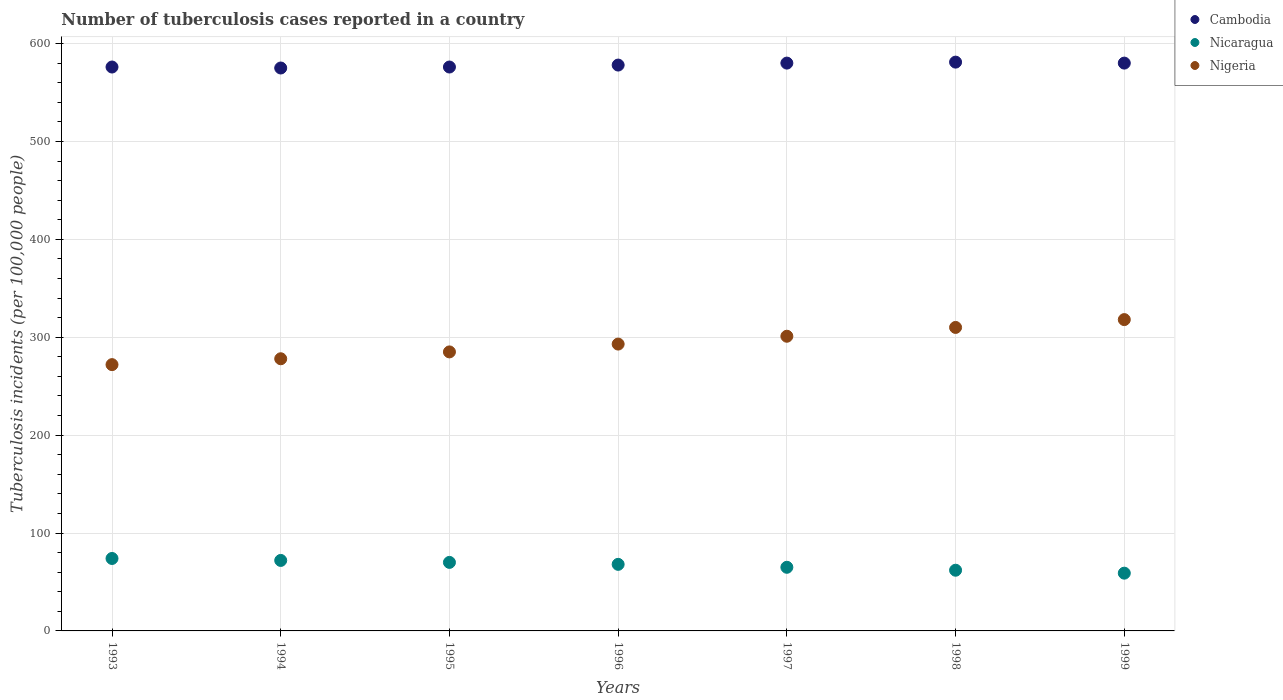How many different coloured dotlines are there?
Your answer should be compact. 3. What is the number of tuberculosis cases reported in in Nigeria in 1995?
Provide a short and direct response. 285. Across all years, what is the maximum number of tuberculosis cases reported in in Cambodia?
Offer a very short reply. 581. Across all years, what is the minimum number of tuberculosis cases reported in in Nicaragua?
Offer a very short reply. 59. In which year was the number of tuberculosis cases reported in in Cambodia maximum?
Make the answer very short. 1998. What is the total number of tuberculosis cases reported in in Nigeria in the graph?
Ensure brevity in your answer.  2057. What is the difference between the number of tuberculosis cases reported in in Nigeria in 1993 and the number of tuberculosis cases reported in in Cambodia in 1994?
Provide a succinct answer. -303. What is the average number of tuberculosis cases reported in in Cambodia per year?
Your answer should be compact. 578. In the year 1998, what is the difference between the number of tuberculosis cases reported in in Nicaragua and number of tuberculosis cases reported in in Nigeria?
Provide a succinct answer. -248. In how many years, is the number of tuberculosis cases reported in in Nicaragua greater than 140?
Make the answer very short. 0. What is the ratio of the number of tuberculosis cases reported in in Nigeria in 1993 to that in 1999?
Provide a succinct answer. 0.86. Is the number of tuberculosis cases reported in in Nicaragua in 1995 less than that in 1996?
Give a very brief answer. No. What is the difference between the highest and the second highest number of tuberculosis cases reported in in Nicaragua?
Give a very brief answer. 2. What is the difference between the highest and the lowest number of tuberculosis cases reported in in Nicaragua?
Offer a terse response. 15. Does the number of tuberculosis cases reported in in Cambodia monotonically increase over the years?
Offer a terse response. No. Is the number of tuberculosis cases reported in in Nicaragua strictly greater than the number of tuberculosis cases reported in in Nigeria over the years?
Make the answer very short. No. Is the number of tuberculosis cases reported in in Cambodia strictly less than the number of tuberculosis cases reported in in Nicaragua over the years?
Your answer should be compact. No. How many dotlines are there?
Provide a succinct answer. 3. How many years are there in the graph?
Your answer should be compact. 7. What is the difference between two consecutive major ticks on the Y-axis?
Give a very brief answer. 100. Are the values on the major ticks of Y-axis written in scientific E-notation?
Ensure brevity in your answer.  No. Does the graph contain any zero values?
Offer a terse response. No. Does the graph contain grids?
Your answer should be very brief. Yes. Where does the legend appear in the graph?
Make the answer very short. Top right. How are the legend labels stacked?
Provide a succinct answer. Vertical. What is the title of the graph?
Your response must be concise. Number of tuberculosis cases reported in a country. What is the label or title of the Y-axis?
Make the answer very short. Tuberculosis incidents (per 100,0 people). What is the Tuberculosis incidents (per 100,000 people) in Cambodia in 1993?
Offer a very short reply. 576. What is the Tuberculosis incidents (per 100,000 people) in Nicaragua in 1993?
Offer a terse response. 74. What is the Tuberculosis incidents (per 100,000 people) of Nigeria in 1993?
Provide a short and direct response. 272. What is the Tuberculosis incidents (per 100,000 people) of Cambodia in 1994?
Give a very brief answer. 575. What is the Tuberculosis incidents (per 100,000 people) of Nigeria in 1994?
Make the answer very short. 278. What is the Tuberculosis incidents (per 100,000 people) in Cambodia in 1995?
Give a very brief answer. 576. What is the Tuberculosis incidents (per 100,000 people) of Nicaragua in 1995?
Give a very brief answer. 70. What is the Tuberculosis incidents (per 100,000 people) of Nigeria in 1995?
Make the answer very short. 285. What is the Tuberculosis incidents (per 100,000 people) of Cambodia in 1996?
Give a very brief answer. 578. What is the Tuberculosis incidents (per 100,000 people) in Nigeria in 1996?
Your answer should be compact. 293. What is the Tuberculosis incidents (per 100,000 people) of Cambodia in 1997?
Provide a succinct answer. 580. What is the Tuberculosis incidents (per 100,000 people) of Nigeria in 1997?
Offer a very short reply. 301. What is the Tuberculosis incidents (per 100,000 people) of Cambodia in 1998?
Offer a very short reply. 581. What is the Tuberculosis incidents (per 100,000 people) in Nicaragua in 1998?
Keep it short and to the point. 62. What is the Tuberculosis incidents (per 100,000 people) in Nigeria in 1998?
Your response must be concise. 310. What is the Tuberculosis incidents (per 100,000 people) in Cambodia in 1999?
Ensure brevity in your answer.  580. What is the Tuberculosis incidents (per 100,000 people) of Nigeria in 1999?
Provide a succinct answer. 318. Across all years, what is the maximum Tuberculosis incidents (per 100,000 people) in Cambodia?
Keep it short and to the point. 581. Across all years, what is the maximum Tuberculosis incidents (per 100,000 people) of Nigeria?
Your answer should be very brief. 318. Across all years, what is the minimum Tuberculosis incidents (per 100,000 people) in Cambodia?
Your answer should be very brief. 575. Across all years, what is the minimum Tuberculosis incidents (per 100,000 people) in Nigeria?
Keep it short and to the point. 272. What is the total Tuberculosis incidents (per 100,000 people) of Cambodia in the graph?
Provide a short and direct response. 4046. What is the total Tuberculosis incidents (per 100,000 people) of Nicaragua in the graph?
Provide a short and direct response. 470. What is the total Tuberculosis incidents (per 100,000 people) of Nigeria in the graph?
Your answer should be very brief. 2057. What is the difference between the Tuberculosis incidents (per 100,000 people) of Cambodia in 1993 and that in 1994?
Ensure brevity in your answer.  1. What is the difference between the Tuberculosis incidents (per 100,000 people) in Nigeria in 1993 and that in 1994?
Your answer should be compact. -6. What is the difference between the Tuberculosis incidents (per 100,000 people) in Cambodia in 1993 and that in 1995?
Provide a succinct answer. 0. What is the difference between the Tuberculosis incidents (per 100,000 people) in Nigeria in 1993 and that in 1995?
Keep it short and to the point. -13. What is the difference between the Tuberculosis incidents (per 100,000 people) in Cambodia in 1993 and that in 1996?
Keep it short and to the point. -2. What is the difference between the Tuberculosis incidents (per 100,000 people) of Nigeria in 1993 and that in 1996?
Your answer should be compact. -21. What is the difference between the Tuberculosis incidents (per 100,000 people) in Cambodia in 1993 and that in 1997?
Provide a succinct answer. -4. What is the difference between the Tuberculosis incidents (per 100,000 people) of Nicaragua in 1993 and that in 1997?
Your response must be concise. 9. What is the difference between the Tuberculosis incidents (per 100,000 people) of Nigeria in 1993 and that in 1997?
Give a very brief answer. -29. What is the difference between the Tuberculosis incidents (per 100,000 people) in Cambodia in 1993 and that in 1998?
Your response must be concise. -5. What is the difference between the Tuberculosis incidents (per 100,000 people) in Nicaragua in 1993 and that in 1998?
Your response must be concise. 12. What is the difference between the Tuberculosis incidents (per 100,000 people) in Nigeria in 1993 and that in 1998?
Offer a terse response. -38. What is the difference between the Tuberculosis incidents (per 100,000 people) of Nigeria in 1993 and that in 1999?
Your response must be concise. -46. What is the difference between the Tuberculosis incidents (per 100,000 people) of Cambodia in 1994 and that in 1995?
Provide a short and direct response. -1. What is the difference between the Tuberculosis incidents (per 100,000 people) of Nicaragua in 1994 and that in 1996?
Offer a very short reply. 4. What is the difference between the Tuberculosis incidents (per 100,000 people) in Cambodia in 1994 and that in 1997?
Your answer should be compact. -5. What is the difference between the Tuberculosis incidents (per 100,000 people) in Nigeria in 1994 and that in 1997?
Provide a succinct answer. -23. What is the difference between the Tuberculosis incidents (per 100,000 people) of Cambodia in 1994 and that in 1998?
Make the answer very short. -6. What is the difference between the Tuberculosis incidents (per 100,000 people) in Nicaragua in 1994 and that in 1998?
Provide a succinct answer. 10. What is the difference between the Tuberculosis incidents (per 100,000 people) of Nigeria in 1994 and that in 1998?
Provide a succinct answer. -32. What is the difference between the Tuberculosis incidents (per 100,000 people) of Nicaragua in 1994 and that in 1999?
Give a very brief answer. 13. What is the difference between the Tuberculosis incidents (per 100,000 people) in Nigeria in 1994 and that in 1999?
Give a very brief answer. -40. What is the difference between the Tuberculosis incidents (per 100,000 people) of Cambodia in 1995 and that in 1996?
Your answer should be compact. -2. What is the difference between the Tuberculosis incidents (per 100,000 people) in Nigeria in 1995 and that in 1996?
Ensure brevity in your answer.  -8. What is the difference between the Tuberculosis incidents (per 100,000 people) of Nicaragua in 1995 and that in 1997?
Give a very brief answer. 5. What is the difference between the Tuberculosis incidents (per 100,000 people) of Nigeria in 1995 and that in 1998?
Your answer should be compact. -25. What is the difference between the Tuberculosis incidents (per 100,000 people) of Cambodia in 1995 and that in 1999?
Give a very brief answer. -4. What is the difference between the Tuberculosis incidents (per 100,000 people) in Nigeria in 1995 and that in 1999?
Offer a terse response. -33. What is the difference between the Tuberculosis incidents (per 100,000 people) of Nicaragua in 1996 and that in 1997?
Your response must be concise. 3. What is the difference between the Tuberculosis incidents (per 100,000 people) of Nigeria in 1996 and that in 1997?
Your answer should be compact. -8. What is the difference between the Tuberculosis incidents (per 100,000 people) of Cambodia in 1996 and that in 1998?
Keep it short and to the point. -3. What is the difference between the Tuberculosis incidents (per 100,000 people) in Nicaragua in 1996 and that in 1998?
Make the answer very short. 6. What is the difference between the Tuberculosis incidents (per 100,000 people) in Nigeria in 1996 and that in 1998?
Make the answer very short. -17. What is the difference between the Tuberculosis incidents (per 100,000 people) in Nicaragua in 1996 and that in 1999?
Your answer should be compact. 9. What is the difference between the Tuberculosis incidents (per 100,000 people) in Nigeria in 1996 and that in 1999?
Give a very brief answer. -25. What is the difference between the Tuberculosis incidents (per 100,000 people) of Cambodia in 1997 and that in 1998?
Give a very brief answer. -1. What is the difference between the Tuberculosis incidents (per 100,000 people) in Cambodia in 1997 and that in 1999?
Make the answer very short. 0. What is the difference between the Tuberculosis incidents (per 100,000 people) in Nicaragua in 1997 and that in 1999?
Make the answer very short. 6. What is the difference between the Tuberculosis incidents (per 100,000 people) in Nigeria in 1998 and that in 1999?
Your answer should be very brief. -8. What is the difference between the Tuberculosis incidents (per 100,000 people) of Cambodia in 1993 and the Tuberculosis incidents (per 100,000 people) of Nicaragua in 1994?
Ensure brevity in your answer.  504. What is the difference between the Tuberculosis incidents (per 100,000 people) of Cambodia in 1993 and the Tuberculosis incidents (per 100,000 people) of Nigeria in 1994?
Your response must be concise. 298. What is the difference between the Tuberculosis incidents (per 100,000 people) of Nicaragua in 1993 and the Tuberculosis incidents (per 100,000 people) of Nigeria in 1994?
Keep it short and to the point. -204. What is the difference between the Tuberculosis incidents (per 100,000 people) of Cambodia in 1993 and the Tuberculosis incidents (per 100,000 people) of Nicaragua in 1995?
Provide a short and direct response. 506. What is the difference between the Tuberculosis incidents (per 100,000 people) in Cambodia in 1993 and the Tuberculosis incidents (per 100,000 people) in Nigeria in 1995?
Give a very brief answer. 291. What is the difference between the Tuberculosis incidents (per 100,000 people) of Nicaragua in 1993 and the Tuberculosis incidents (per 100,000 people) of Nigeria in 1995?
Provide a short and direct response. -211. What is the difference between the Tuberculosis incidents (per 100,000 people) in Cambodia in 1993 and the Tuberculosis incidents (per 100,000 people) in Nicaragua in 1996?
Offer a terse response. 508. What is the difference between the Tuberculosis incidents (per 100,000 people) in Cambodia in 1993 and the Tuberculosis incidents (per 100,000 people) in Nigeria in 1996?
Your answer should be very brief. 283. What is the difference between the Tuberculosis incidents (per 100,000 people) in Nicaragua in 1993 and the Tuberculosis incidents (per 100,000 people) in Nigeria in 1996?
Provide a short and direct response. -219. What is the difference between the Tuberculosis incidents (per 100,000 people) in Cambodia in 1993 and the Tuberculosis incidents (per 100,000 people) in Nicaragua in 1997?
Give a very brief answer. 511. What is the difference between the Tuberculosis incidents (per 100,000 people) of Cambodia in 1993 and the Tuberculosis incidents (per 100,000 people) of Nigeria in 1997?
Your response must be concise. 275. What is the difference between the Tuberculosis incidents (per 100,000 people) in Nicaragua in 1993 and the Tuberculosis incidents (per 100,000 people) in Nigeria in 1997?
Offer a very short reply. -227. What is the difference between the Tuberculosis incidents (per 100,000 people) of Cambodia in 1993 and the Tuberculosis incidents (per 100,000 people) of Nicaragua in 1998?
Provide a short and direct response. 514. What is the difference between the Tuberculosis incidents (per 100,000 people) in Cambodia in 1993 and the Tuberculosis incidents (per 100,000 people) in Nigeria in 1998?
Offer a terse response. 266. What is the difference between the Tuberculosis incidents (per 100,000 people) of Nicaragua in 1993 and the Tuberculosis incidents (per 100,000 people) of Nigeria in 1998?
Provide a short and direct response. -236. What is the difference between the Tuberculosis incidents (per 100,000 people) in Cambodia in 1993 and the Tuberculosis incidents (per 100,000 people) in Nicaragua in 1999?
Offer a very short reply. 517. What is the difference between the Tuberculosis incidents (per 100,000 people) of Cambodia in 1993 and the Tuberculosis incidents (per 100,000 people) of Nigeria in 1999?
Offer a very short reply. 258. What is the difference between the Tuberculosis incidents (per 100,000 people) in Nicaragua in 1993 and the Tuberculosis incidents (per 100,000 people) in Nigeria in 1999?
Ensure brevity in your answer.  -244. What is the difference between the Tuberculosis incidents (per 100,000 people) in Cambodia in 1994 and the Tuberculosis incidents (per 100,000 people) in Nicaragua in 1995?
Offer a very short reply. 505. What is the difference between the Tuberculosis incidents (per 100,000 people) in Cambodia in 1994 and the Tuberculosis incidents (per 100,000 people) in Nigeria in 1995?
Offer a terse response. 290. What is the difference between the Tuberculosis incidents (per 100,000 people) in Nicaragua in 1994 and the Tuberculosis incidents (per 100,000 people) in Nigeria in 1995?
Your answer should be very brief. -213. What is the difference between the Tuberculosis incidents (per 100,000 people) in Cambodia in 1994 and the Tuberculosis incidents (per 100,000 people) in Nicaragua in 1996?
Your answer should be very brief. 507. What is the difference between the Tuberculosis incidents (per 100,000 people) of Cambodia in 1994 and the Tuberculosis incidents (per 100,000 people) of Nigeria in 1996?
Offer a terse response. 282. What is the difference between the Tuberculosis incidents (per 100,000 people) in Nicaragua in 1994 and the Tuberculosis incidents (per 100,000 people) in Nigeria in 1996?
Make the answer very short. -221. What is the difference between the Tuberculosis incidents (per 100,000 people) of Cambodia in 1994 and the Tuberculosis incidents (per 100,000 people) of Nicaragua in 1997?
Ensure brevity in your answer.  510. What is the difference between the Tuberculosis incidents (per 100,000 people) in Cambodia in 1994 and the Tuberculosis incidents (per 100,000 people) in Nigeria in 1997?
Your answer should be very brief. 274. What is the difference between the Tuberculosis incidents (per 100,000 people) of Nicaragua in 1994 and the Tuberculosis incidents (per 100,000 people) of Nigeria in 1997?
Keep it short and to the point. -229. What is the difference between the Tuberculosis incidents (per 100,000 people) of Cambodia in 1994 and the Tuberculosis incidents (per 100,000 people) of Nicaragua in 1998?
Offer a terse response. 513. What is the difference between the Tuberculosis incidents (per 100,000 people) of Cambodia in 1994 and the Tuberculosis incidents (per 100,000 people) of Nigeria in 1998?
Offer a very short reply. 265. What is the difference between the Tuberculosis incidents (per 100,000 people) in Nicaragua in 1994 and the Tuberculosis incidents (per 100,000 people) in Nigeria in 1998?
Your answer should be compact. -238. What is the difference between the Tuberculosis incidents (per 100,000 people) in Cambodia in 1994 and the Tuberculosis incidents (per 100,000 people) in Nicaragua in 1999?
Offer a terse response. 516. What is the difference between the Tuberculosis incidents (per 100,000 people) in Cambodia in 1994 and the Tuberculosis incidents (per 100,000 people) in Nigeria in 1999?
Your answer should be compact. 257. What is the difference between the Tuberculosis incidents (per 100,000 people) in Nicaragua in 1994 and the Tuberculosis incidents (per 100,000 people) in Nigeria in 1999?
Offer a very short reply. -246. What is the difference between the Tuberculosis incidents (per 100,000 people) of Cambodia in 1995 and the Tuberculosis incidents (per 100,000 people) of Nicaragua in 1996?
Offer a very short reply. 508. What is the difference between the Tuberculosis incidents (per 100,000 people) in Cambodia in 1995 and the Tuberculosis incidents (per 100,000 people) in Nigeria in 1996?
Offer a very short reply. 283. What is the difference between the Tuberculosis incidents (per 100,000 people) of Nicaragua in 1995 and the Tuberculosis incidents (per 100,000 people) of Nigeria in 1996?
Your answer should be very brief. -223. What is the difference between the Tuberculosis incidents (per 100,000 people) in Cambodia in 1995 and the Tuberculosis incidents (per 100,000 people) in Nicaragua in 1997?
Give a very brief answer. 511. What is the difference between the Tuberculosis incidents (per 100,000 people) in Cambodia in 1995 and the Tuberculosis incidents (per 100,000 people) in Nigeria in 1997?
Ensure brevity in your answer.  275. What is the difference between the Tuberculosis incidents (per 100,000 people) in Nicaragua in 1995 and the Tuberculosis incidents (per 100,000 people) in Nigeria in 1997?
Give a very brief answer. -231. What is the difference between the Tuberculosis incidents (per 100,000 people) in Cambodia in 1995 and the Tuberculosis incidents (per 100,000 people) in Nicaragua in 1998?
Make the answer very short. 514. What is the difference between the Tuberculosis incidents (per 100,000 people) in Cambodia in 1995 and the Tuberculosis incidents (per 100,000 people) in Nigeria in 1998?
Your response must be concise. 266. What is the difference between the Tuberculosis incidents (per 100,000 people) in Nicaragua in 1995 and the Tuberculosis incidents (per 100,000 people) in Nigeria in 1998?
Your response must be concise. -240. What is the difference between the Tuberculosis incidents (per 100,000 people) of Cambodia in 1995 and the Tuberculosis incidents (per 100,000 people) of Nicaragua in 1999?
Provide a short and direct response. 517. What is the difference between the Tuberculosis incidents (per 100,000 people) in Cambodia in 1995 and the Tuberculosis incidents (per 100,000 people) in Nigeria in 1999?
Give a very brief answer. 258. What is the difference between the Tuberculosis incidents (per 100,000 people) in Nicaragua in 1995 and the Tuberculosis incidents (per 100,000 people) in Nigeria in 1999?
Ensure brevity in your answer.  -248. What is the difference between the Tuberculosis incidents (per 100,000 people) of Cambodia in 1996 and the Tuberculosis incidents (per 100,000 people) of Nicaragua in 1997?
Make the answer very short. 513. What is the difference between the Tuberculosis incidents (per 100,000 people) of Cambodia in 1996 and the Tuberculosis incidents (per 100,000 people) of Nigeria in 1997?
Keep it short and to the point. 277. What is the difference between the Tuberculosis incidents (per 100,000 people) in Nicaragua in 1996 and the Tuberculosis incidents (per 100,000 people) in Nigeria in 1997?
Your response must be concise. -233. What is the difference between the Tuberculosis incidents (per 100,000 people) of Cambodia in 1996 and the Tuberculosis incidents (per 100,000 people) of Nicaragua in 1998?
Your response must be concise. 516. What is the difference between the Tuberculosis incidents (per 100,000 people) in Cambodia in 1996 and the Tuberculosis incidents (per 100,000 people) in Nigeria in 1998?
Ensure brevity in your answer.  268. What is the difference between the Tuberculosis incidents (per 100,000 people) of Nicaragua in 1996 and the Tuberculosis incidents (per 100,000 people) of Nigeria in 1998?
Give a very brief answer. -242. What is the difference between the Tuberculosis incidents (per 100,000 people) of Cambodia in 1996 and the Tuberculosis incidents (per 100,000 people) of Nicaragua in 1999?
Your response must be concise. 519. What is the difference between the Tuberculosis incidents (per 100,000 people) of Cambodia in 1996 and the Tuberculosis incidents (per 100,000 people) of Nigeria in 1999?
Ensure brevity in your answer.  260. What is the difference between the Tuberculosis incidents (per 100,000 people) of Nicaragua in 1996 and the Tuberculosis incidents (per 100,000 people) of Nigeria in 1999?
Provide a succinct answer. -250. What is the difference between the Tuberculosis incidents (per 100,000 people) in Cambodia in 1997 and the Tuberculosis incidents (per 100,000 people) in Nicaragua in 1998?
Your answer should be compact. 518. What is the difference between the Tuberculosis incidents (per 100,000 people) in Cambodia in 1997 and the Tuberculosis incidents (per 100,000 people) in Nigeria in 1998?
Give a very brief answer. 270. What is the difference between the Tuberculosis incidents (per 100,000 people) of Nicaragua in 1997 and the Tuberculosis incidents (per 100,000 people) of Nigeria in 1998?
Give a very brief answer. -245. What is the difference between the Tuberculosis incidents (per 100,000 people) in Cambodia in 1997 and the Tuberculosis incidents (per 100,000 people) in Nicaragua in 1999?
Your answer should be compact. 521. What is the difference between the Tuberculosis incidents (per 100,000 people) of Cambodia in 1997 and the Tuberculosis incidents (per 100,000 people) of Nigeria in 1999?
Give a very brief answer. 262. What is the difference between the Tuberculosis incidents (per 100,000 people) in Nicaragua in 1997 and the Tuberculosis incidents (per 100,000 people) in Nigeria in 1999?
Ensure brevity in your answer.  -253. What is the difference between the Tuberculosis incidents (per 100,000 people) of Cambodia in 1998 and the Tuberculosis incidents (per 100,000 people) of Nicaragua in 1999?
Keep it short and to the point. 522. What is the difference between the Tuberculosis incidents (per 100,000 people) of Cambodia in 1998 and the Tuberculosis incidents (per 100,000 people) of Nigeria in 1999?
Provide a short and direct response. 263. What is the difference between the Tuberculosis incidents (per 100,000 people) in Nicaragua in 1998 and the Tuberculosis incidents (per 100,000 people) in Nigeria in 1999?
Keep it short and to the point. -256. What is the average Tuberculosis incidents (per 100,000 people) in Cambodia per year?
Keep it short and to the point. 578. What is the average Tuberculosis incidents (per 100,000 people) of Nicaragua per year?
Keep it short and to the point. 67.14. What is the average Tuberculosis incidents (per 100,000 people) in Nigeria per year?
Ensure brevity in your answer.  293.86. In the year 1993, what is the difference between the Tuberculosis incidents (per 100,000 people) of Cambodia and Tuberculosis incidents (per 100,000 people) of Nicaragua?
Offer a very short reply. 502. In the year 1993, what is the difference between the Tuberculosis incidents (per 100,000 people) of Cambodia and Tuberculosis incidents (per 100,000 people) of Nigeria?
Your answer should be compact. 304. In the year 1993, what is the difference between the Tuberculosis incidents (per 100,000 people) of Nicaragua and Tuberculosis incidents (per 100,000 people) of Nigeria?
Offer a terse response. -198. In the year 1994, what is the difference between the Tuberculosis incidents (per 100,000 people) in Cambodia and Tuberculosis incidents (per 100,000 people) in Nicaragua?
Ensure brevity in your answer.  503. In the year 1994, what is the difference between the Tuberculosis incidents (per 100,000 people) in Cambodia and Tuberculosis incidents (per 100,000 people) in Nigeria?
Provide a short and direct response. 297. In the year 1994, what is the difference between the Tuberculosis incidents (per 100,000 people) of Nicaragua and Tuberculosis incidents (per 100,000 people) of Nigeria?
Your answer should be very brief. -206. In the year 1995, what is the difference between the Tuberculosis incidents (per 100,000 people) of Cambodia and Tuberculosis incidents (per 100,000 people) of Nicaragua?
Your answer should be very brief. 506. In the year 1995, what is the difference between the Tuberculosis incidents (per 100,000 people) of Cambodia and Tuberculosis incidents (per 100,000 people) of Nigeria?
Provide a short and direct response. 291. In the year 1995, what is the difference between the Tuberculosis incidents (per 100,000 people) of Nicaragua and Tuberculosis incidents (per 100,000 people) of Nigeria?
Ensure brevity in your answer.  -215. In the year 1996, what is the difference between the Tuberculosis incidents (per 100,000 people) of Cambodia and Tuberculosis incidents (per 100,000 people) of Nicaragua?
Your answer should be very brief. 510. In the year 1996, what is the difference between the Tuberculosis incidents (per 100,000 people) in Cambodia and Tuberculosis incidents (per 100,000 people) in Nigeria?
Your answer should be compact. 285. In the year 1996, what is the difference between the Tuberculosis incidents (per 100,000 people) of Nicaragua and Tuberculosis incidents (per 100,000 people) of Nigeria?
Ensure brevity in your answer.  -225. In the year 1997, what is the difference between the Tuberculosis incidents (per 100,000 people) in Cambodia and Tuberculosis incidents (per 100,000 people) in Nicaragua?
Give a very brief answer. 515. In the year 1997, what is the difference between the Tuberculosis incidents (per 100,000 people) of Cambodia and Tuberculosis incidents (per 100,000 people) of Nigeria?
Provide a short and direct response. 279. In the year 1997, what is the difference between the Tuberculosis incidents (per 100,000 people) in Nicaragua and Tuberculosis incidents (per 100,000 people) in Nigeria?
Provide a short and direct response. -236. In the year 1998, what is the difference between the Tuberculosis incidents (per 100,000 people) in Cambodia and Tuberculosis incidents (per 100,000 people) in Nicaragua?
Your answer should be compact. 519. In the year 1998, what is the difference between the Tuberculosis incidents (per 100,000 people) in Cambodia and Tuberculosis incidents (per 100,000 people) in Nigeria?
Your answer should be very brief. 271. In the year 1998, what is the difference between the Tuberculosis incidents (per 100,000 people) in Nicaragua and Tuberculosis incidents (per 100,000 people) in Nigeria?
Keep it short and to the point. -248. In the year 1999, what is the difference between the Tuberculosis incidents (per 100,000 people) in Cambodia and Tuberculosis incidents (per 100,000 people) in Nicaragua?
Your answer should be compact. 521. In the year 1999, what is the difference between the Tuberculosis incidents (per 100,000 people) of Cambodia and Tuberculosis incidents (per 100,000 people) of Nigeria?
Ensure brevity in your answer.  262. In the year 1999, what is the difference between the Tuberculosis incidents (per 100,000 people) of Nicaragua and Tuberculosis incidents (per 100,000 people) of Nigeria?
Your answer should be very brief. -259. What is the ratio of the Tuberculosis incidents (per 100,000 people) of Nicaragua in 1993 to that in 1994?
Give a very brief answer. 1.03. What is the ratio of the Tuberculosis incidents (per 100,000 people) of Nigeria in 1993 to that in 1994?
Make the answer very short. 0.98. What is the ratio of the Tuberculosis incidents (per 100,000 people) of Cambodia in 1993 to that in 1995?
Your response must be concise. 1. What is the ratio of the Tuberculosis incidents (per 100,000 people) in Nicaragua in 1993 to that in 1995?
Provide a short and direct response. 1.06. What is the ratio of the Tuberculosis incidents (per 100,000 people) of Nigeria in 1993 to that in 1995?
Your answer should be compact. 0.95. What is the ratio of the Tuberculosis incidents (per 100,000 people) of Nicaragua in 1993 to that in 1996?
Offer a terse response. 1.09. What is the ratio of the Tuberculosis incidents (per 100,000 people) in Nigeria in 1993 to that in 1996?
Your answer should be very brief. 0.93. What is the ratio of the Tuberculosis incidents (per 100,000 people) of Cambodia in 1993 to that in 1997?
Offer a terse response. 0.99. What is the ratio of the Tuberculosis incidents (per 100,000 people) of Nicaragua in 1993 to that in 1997?
Your response must be concise. 1.14. What is the ratio of the Tuberculosis incidents (per 100,000 people) of Nigeria in 1993 to that in 1997?
Your answer should be compact. 0.9. What is the ratio of the Tuberculosis incidents (per 100,000 people) of Cambodia in 1993 to that in 1998?
Provide a short and direct response. 0.99. What is the ratio of the Tuberculosis incidents (per 100,000 people) in Nicaragua in 1993 to that in 1998?
Make the answer very short. 1.19. What is the ratio of the Tuberculosis incidents (per 100,000 people) of Nigeria in 1993 to that in 1998?
Provide a short and direct response. 0.88. What is the ratio of the Tuberculosis incidents (per 100,000 people) in Cambodia in 1993 to that in 1999?
Give a very brief answer. 0.99. What is the ratio of the Tuberculosis incidents (per 100,000 people) in Nicaragua in 1993 to that in 1999?
Offer a very short reply. 1.25. What is the ratio of the Tuberculosis incidents (per 100,000 people) of Nigeria in 1993 to that in 1999?
Provide a short and direct response. 0.86. What is the ratio of the Tuberculosis incidents (per 100,000 people) of Nicaragua in 1994 to that in 1995?
Make the answer very short. 1.03. What is the ratio of the Tuberculosis incidents (per 100,000 people) of Nigeria in 1994 to that in 1995?
Offer a terse response. 0.98. What is the ratio of the Tuberculosis incidents (per 100,000 people) of Nicaragua in 1994 to that in 1996?
Make the answer very short. 1.06. What is the ratio of the Tuberculosis incidents (per 100,000 people) of Nigeria in 1994 to that in 1996?
Your answer should be very brief. 0.95. What is the ratio of the Tuberculosis incidents (per 100,000 people) in Nicaragua in 1994 to that in 1997?
Keep it short and to the point. 1.11. What is the ratio of the Tuberculosis incidents (per 100,000 people) in Nigeria in 1994 to that in 1997?
Provide a short and direct response. 0.92. What is the ratio of the Tuberculosis incidents (per 100,000 people) of Nicaragua in 1994 to that in 1998?
Offer a terse response. 1.16. What is the ratio of the Tuberculosis incidents (per 100,000 people) in Nigeria in 1994 to that in 1998?
Make the answer very short. 0.9. What is the ratio of the Tuberculosis incidents (per 100,000 people) in Cambodia in 1994 to that in 1999?
Provide a succinct answer. 0.99. What is the ratio of the Tuberculosis incidents (per 100,000 people) of Nicaragua in 1994 to that in 1999?
Keep it short and to the point. 1.22. What is the ratio of the Tuberculosis incidents (per 100,000 people) in Nigeria in 1994 to that in 1999?
Provide a succinct answer. 0.87. What is the ratio of the Tuberculosis incidents (per 100,000 people) of Cambodia in 1995 to that in 1996?
Give a very brief answer. 1. What is the ratio of the Tuberculosis incidents (per 100,000 people) in Nicaragua in 1995 to that in 1996?
Offer a terse response. 1.03. What is the ratio of the Tuberculosis incidents (per 100,000 people) of Nigeria in 1995 to that in 1996?
Give a very brief answer. 0.97. What is the ratio of the Tuberculosis incidents (per 100,000 people) of Nigeria in 1995 to that in 1997?
Offer a very short reply. 0.95. What is the ratio of the Tuberculosis incidents (per 100,000 people) in Cambodia in 1995 to that in 1998?
Your response must be concise. 0.99. What is the ratio of the Tuberculosis incidents (per 100,000 people) in Nicaragua in 1995 to that in 1998?
Your answer should be very brief. 1.13. What is the ratio of the Tuberculosis incidents (per 100,000 people) in Nigeria in 1995 to that in 1998?
Offer a very short reply. 0.92. What is the ratio of the Tuberculosis incidents (per 100,000 people) in Cambodia in 1995 to that in 1999?
Keep it short and to the point. 0.99. What is the ratio of the Tuberculosis incidents (per 100,000 people) in Nicaragua in 1995 to that in 1999?
Ensure brevity in your answer.  1.19. What is the ratio of the Tuberculosis incidents (per 100,000 people) of Nigeria in 1995 to that in 1999?
Your answer should be very brief. 0.9. What is the ratio of the Tuberculosis incidents (per 100,000 people) in Cambodia in 1996 to that in 1997?
Offer a terse response. 1. What is the ratio of the Tuberculosis incidents (per 100,000 people) in Nicaragua in 1996 to that in 1997?
Offer a terse response. 1.05. What is the ratio of the Tuberculosis incidents (per 100,000 people) of Nigeria in 1996 to that in 1997?
Give a very brief answer. 0.97. What is the ratio of the Tuberculosis incidents (per 100,000 people) of Nicaragua in 1996 to that in 1998?
Provide a succinct answer. 1.1. What is the ratio of the Tuberculosis incidents (per 100,000 people) of Nigeria in 1996 to that in 1998?
Give a very brief answer. 0.95. What is the ratio of the Tuberculosis incidents (per 100,000 people) in Cambodia in 1996 to that in 1999?
Offer a very short reply. 1. What is the ratio of the Tuberculosis incidents (per 100,000 people) of Nicaragua in 1996 to that in 1999?
Your response must be concise. 1.15. What is the ratio of the Tuberculosis incidents (per 100,000 people) of Nigeria in 1996 to that in 1999?
Make the answer very short. 0.92. What is the ratio of the Tuberculosis incidents (per 100,000 people) in Nicaragua in 1997 to that in 1998?
Your answer should be very brief. 1.05. What is the ratio of the Tuberculosis incidents (per 100,000 people) in Nigeria in 1997 to that in 1998?
Provide a succinct answer. 0.97. What is the ratio of the Tuberculosis incidents (per 100,000 people) in Cambodia in 1997 to that in 1999?
Offer a very short reply. 1. What is the ratio of the Tuberculosis incidents (per 100,000 people) in Nicaragua in 1997 to that in 1999?
Offer a terse response. 1.1. What is the ratio of the Tuberculosis incidents (per 100,000 people) of Nigeria in 1997 to that in 1999?
Your answer should be compact. 0.95. What is the ratio of the Tuberculosis incidents (per 100,000 people) of Nicaragua in 1998 to that in 1999?
Keep it short and to the point. 1.05. What is the ratio of the Tuberculosis incidents (per 100,000 people) of Nigeria in 1998 to that in 1999?
Your answer should be compact. 0.97. What is the difference between the highest and the second highest Tuberculosis incidents (per 100,000 people) of Nigeria?
Give a very brief answer. 8. What is the difference between the highest and the lowest Tuberculosis incidents (per 100,000 people) of Cambodia?
Your answer should be compact. 6. What is the difference between the highest and the lowest Tuberculosis incidents (per 100,000 people) of Nicaragua?
Make the answer very short. 15. 